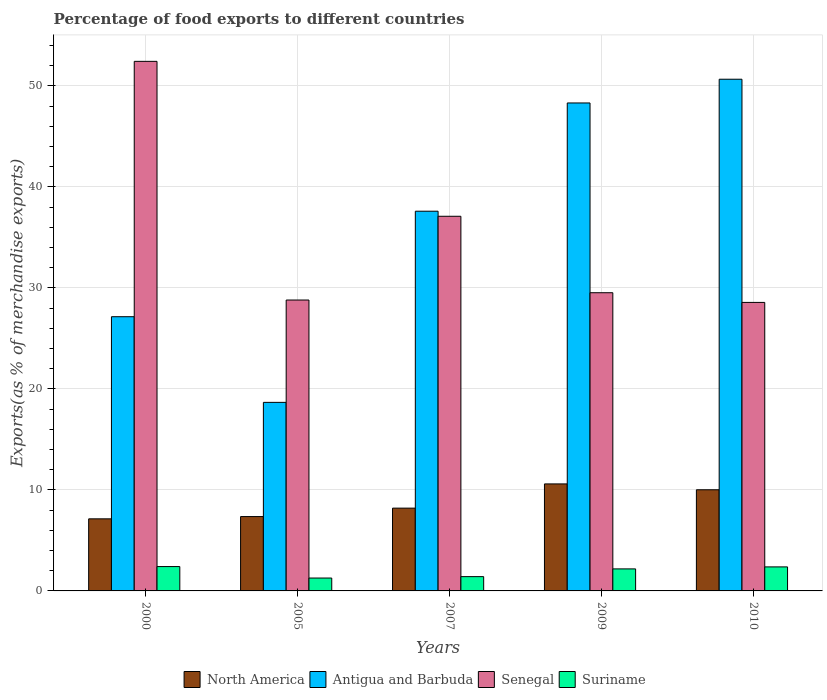How many groups of bars are there?
Offer a very short reply. 5. Are the number of bars per tick equal to the number of legend labels?
Your response must be concise. Yes. Are the number of bars on each tick of the X-axis equal?
Offer a terse response. Yes. How many bars are there on the 3rd tick from the right?
Ensure brevity in your answer.  4. What is the percentage of exports to different countries in Senegal in 2007?
Keep it short and to the point. 37.09. Across all years, what is the maximum percentage of exports to different countries in Suriname?
Keep it short and to the point. 2.41. Across all years, what is the minimum percentage of exports to different countries in Antigua and Barbuda?
Make the answer very short. 18.66. In which year was the percentage of exports to different countries in Senegal maximum?
Ensure brevity in your answer.  2000. What is the total percentage of exports to different countries in Senegal in the graph?
Provide a succinct answer. 176.39. What is the difference between the percentage of exports to different countries in Antigua and Barbuda in 2009 and that in 2010?
Ensure brevity in your answer.  -2.35. What is the difference between the percentage of exports to different countries in Senegal in 2000 and the percentage of exports to different countries in Suriname in 2007?
Offer a terse response. 51.01. What is the average percentage of exports to different countries in North America per year?
Your answer should be compact. 8.66. In the year 2005, what is the difference between the percentage of exports to different countries in Antigua and Barbuda and percentage of exports to different countries in North America?
Provide a short and direct response. 11.3. In how many years, is the percentage of exports to different countries in North America greater than 16 %?
Your answer should be compact. 0. What is the ratio of the percentage of exports to different countries in Antigua and Barbuda in 2000 to that in 2010?
Give a very brief answer. 0.54. Is the difference between the percentage of exports to different countries in Antigua and Barbuda in 2005 and 2010 greater than the difference between the percentage of exports to different countries in North America in 2005 and 2010?
Your response must be concise. No. What is the difference between the highest and the second highest percentage of exports to different countries in Senegal?
Your answer should be very brief. 15.34. What is the difference between the highest and the lowest percentage of exports to different countries in Senegal?
Provide a succinct answer. 23.86. In how many years, is the percentage of exports to different countries in Senegal greater than the average percentage of exports to different countries in Senegal taken over all years?
Your answer should be very brief. 2. What does the 2nd bar from the left in 2000 represents?
Offer a terse response. Antigua and Barbuda. What does the 3rd bar from the right in 2009 represents?
Make the answer very short. Antigua and Barbuda. Is it the case that in every year, the sum of the percentage of exports to different countries in Senegal and percentage of exports to different countries in North America is greater than the percentage of exports to different countries in Suriname?
Ensure brevity in your answer.  Yes. How many bars are there?
Your response must be concise. 20. Are the values on the major ticks of Y-axis written in scientific E-notation?
Your response must be concise. No. Does the graph contain any zero values?
Offer a terse response. No. How many legend labels are there?
Provide a succinct answer. 4. How are the legend labels stacked?
Give a very brief answer. Horizontal. What is the title of the graph?
Your answer should be compact. Percentage of food exports to different countries. What is the label or title of the X-axis?
Provide a succinct answer. Years. What is the label or title of the Y-axis?
Offer a terse response. Exports(as % of merchandise exports). What is the Exports(as % of merchandise exports) in North America in 2000?
Make the answer very short. 7.14. What is the Exports(as % of merchandise exports) of Antigua and Barbuda in 2000?
Keep it short and to the point. 27.15. What is the Exports(as % of merchandise exports) of Senegal in 2000?
Provide a short and direct response. 52.42. What is the Exports(as % of merchandise exports) in Suriname in 2000?
Ensure brevity in your answer.  2.41. What is the Exports(as % of merchandise exports) in North America in 2005?
Your answer should be compact. 7.36. What is the Exports(as % of merchandise exports) in Antigua and Barbuda in 2005?
Keep it short and to the point. 18.66. What is the Exports(as % of merchandise exports) in Senegal in 2005?
Offer a terse response. 28.8. What is the Exports(as % of merchandise exports) of Suriname in 2005?
Give a very brief answer. 1.27. What is the Exports(as % of merchandise exports) of North America in 2007?
Your answer should be very brief. 8.2. What is the Exports(as % of merchandise exports) in Antigua and Barbuda in 2007?
Offer a terse response. 37.59. What is the Exports(as % of merchandise exports) in Senegal in 2007?
Make the answer very short. 37.09. What is the Exports(as % of merchandise exports) of Suriname in 2007?
Your answer should be very brief. 1.42. What is the Exports(as % of merchandise exports) of North America in 2009?
Offer a terse response. 10.59. What is the Exports(as % of merchandise exports) of Antigua and Barbuda in 2009?
Offer a very short reply. 48.31. What is the Exports(as % of merchandise exports) in Senegal in 2009?
Provide a short and direct response. 29.52. What is the Exports(as % of merchandise exports) in Suriname in 2009?
Provide a short and direct response. 2.18. What is the Exports(as % of merchandise exports) of North America in 2010?
Make the answer very short. 10.01. What is the Exports(as % of merchandise exports) of Antigua and Barbuda in 2010?
Offer a terse response. 50.65. What is the Exports(as % of merchandise exports) of Senegal in 2010?
Offer a very short reply. 28.56. What is the Exports(as % of merchandise exports) of Suriname in 2010?
Your answer should be compact. 2.38. Across all years, what is the maximum Exports(as % of merchandise exports) of North America?
Your response must be concise. 10.59. Across all years, what is the maximum Exports(as % of merchandise exports) in Antigua and Barbuda?
Make the answer very short. 50.65. Across all years, what is the maximum Exports(as % of merchandise exports) of Senegal?
Provide a succinct answer. 52.42. Across all years, what is the maximum Exports(as % of merchandise exports) in Suriname?
Offer a terse response. 2.41. Across all years, what is the minimum Exports(as % of merchandise exports) in North America?
Ensure brevity in your answer.  7.14. Across all years, what is the minimum Exports(as % of merchandise exports) in Antigua and Barbuda?
Your response must be concise. 18.66. Across all years, what is the minimum Exports(as % of merchandise exports) in Senegal?
Make the answer very short. 28.56. Across all years, what is the minimum Exports(as % of merchandise exports) of Suriname?
Keep it short and to the point. 1.27. What is the total Exports(as % of merchandise exports) in North America in the graph?
Offer a very short reply. 43.3. What is the total Exports(as % of merchandise exports) of Antigua and Barbuda in the graph?
Offer a very short reply. 182.36. What is the total Exports(as % of merchandise exports) of Senegal in the graph?
Your answer should be very brief. 176.39. What is the total Exports(as % of merchandise exports) in Suriname in the graph?
Provide a short and direct response. 9.66. What is the difference between the Exports(as % of merchandise exports) of North America in 2000 and that in 2005?
Your answer should be compact. -0.22. What is the difference between the Exports(as % of merchandise exports) of Antigua and Barbuda in 2000 and that in 2005?
Offer a very short reply. 8.48. What is the difference between the Exports(as % of merchandise exports) of Senegal in 2000 and that in 2005?
Offer a very short reply. 23.63. What is the difference between the Exports(as % of merchandise exports) of Suriname in 2000 and that in 2005?
Give a very brief answer. 1.14. What is the difference between the Exports(as % of merchandise exports) of North America in 2000 and that in 2007?
Your answer should be very brief. -1.06. What is the difference between the Exports(as % of merchandise exports) in Antigua and Barbuda in 2000 and that in 2007?
Your answer should be very brief. -10.44. What is the difference between the Exports(as % of merchandise exports) in Senegal in 2000 and that in 2007?
Your response must be concise. 15.34. What is the difference between the Exports(as % of merchandise exports) in North America in 2000 and that in 2009?
Offer a very short reply. -3.46. What is the difference between the Exports(as % of merchandise exports) in Antigua and Barbuda in 2000 and that in 2009?
Your answer should be compact. -21.16. What is the difference between the Exports(as % of merchandise exports) of Senegal in 2000 and that in 2009?
Your answer should be very brief. 22.9. What is the difference between the Exports(as % of merchandise exports) of Suriname in 2000 and that in 2009?
Give a very brief answer. 0.23. What is the difference between the Exports(as % of merchandise exports) of North America in 2000 and that in 2010?
Ensure brevity in your answer.  -2.88. What is the difference between the Exports(as % of merchandise exports) of Antigua and Barbuda in 2000 and that in 2010?
Offer a terse response. -23.51. What is the difference between the Exports(as % of merchandise exports) of Senegal in 2000 and that in 2010?
Your response must be concise. 23.86. What is the difference between the Exports(as % of merchandise exports) of Suriname in 2000 and that in 2010?
Provide a short and direct response. 0.03. What is the difference between the Exports(as % of merchandise exports) in North America in 2005 and that in 2007?
Give a very brief answer. -0.84. What is the difference between the Exports(as % of merchandise exports) of Antigua and Barbuda in 2005 and that in 2007?
Provide a short and direct response. -18.92. What is the difference between the Exports(as % of merchandise exports) in Senegal in 2005 and that in 2007?
Provide a succinct answer. -8.29. What is the difference between the Exports(as % of merchandise exports) of Suriname in 2005 and that in 2007?
Ensure brevity in your answer.  -0.14. What is the difference between the Exports(as % of merchandise exports) of North America in 2005 and that in 2009?
Ensure brevity in your answer.  -3.23. What is the difference between the Exports(as % of merchandise exports) of Antigua and Barbuda in 2005 and that in 2009?
Provide a succinct answer. -29.64. What is the difference between the Exports(as % of merchandise exports) of Senegal in 2005 and that in 2009?
Give a very brief answer. -0.72. What is the difference between the Exports(as % of merchandise exports) in Suriname in 2005 and that in 2009?
Offer a very short reply. -0.9. What is the difference between the Exports(as % of merchandise exports) of North America in 2005 and that in 2010?
Make the answer very short. -2.65. What is the difference between the Exports(as % of merchandise exports) in Antigua and Barbuda in 2005 and that in 2010?
Ensure brevity in your answer.  -31.99. What is the difference between the Exports(as % of merchandise exports) in Senegal in 2005 and that in 2010?
Your answer should be very brief. 0.24. What is the difference between the Exports(as % of merchandise exports) in Suriname in 2005 and that in 2010?
Provide a succinct answer. -1.1. What is the difference between the Exports(as % of merchandise exports) of North America in 2007 and that in 2009?
Offer a very short reply. -2.4. What is the difference between the Exports(as % of merchandise exports) of Antigua and Barbuda in 2007 and that in 2009?
Keep it short and to the point. -10.72. What is the difference between the Exports(as % of merchandise exports) in Senegal in 2007 and that in 2009?
Give a very brief answer. 7.57. What is the difference between the Exports(as % of merchandise exports) of Suriname in 2007 and that in 2009?
Provide a succinct answer. -0.76. What is the difference between the Exports(as % of merchandise exports) in North America in 2007 and that in 2010?
Your response must be concise. -1.82. What is the difference between the Exports(as % of merchandise exports) of Antigua and Barbuda in 2007 and that in 2010?
Ensure brevity in your answer.  -13.07. What is the difference between the Exports(as % of merchandise exports) of Senegal in 2007 and that in 2010?
Offer a terse response. 8.53. What is the difference between the Exports(as % of merchandise exports) of Suriname in 2007 and that in 2010?
Your answer should be compact. -0.96. What is the difference between the Exports(as % of merchandise exports) in North America in 2009 and that in 2010?
Your response must be concise. 0.58. What is the difference between the Exports(as % of merchandise exports) of Antigua and Barbuda in 2009 and that in 2010?
Offer a very short reply. -2.35. What is the difference between the Exports(as % of merchandise exports) of Senegal in 2009 and that in 2010?
Make the answer very short. 0.96. What is the difference between the Exports(as % of merchandise exports) in Suriname in 2009 and that in 2010?
Offer a very short reply. -0.2. What is the difference between the Exports(as % of merchandise exports) of North America in 2000 and the Exports(as % of merchandise exports) of Antigua and Barbuda in 2005?
Offer a terse response. -11.53. What is the difference between the Exports(as % of merchandise exports) in North America in 2000 and the Exports(as % of merchandise exports) in Senegal in 2005?
Offer a terse response. -21.66. What is the difference between the Exports(as % of merchandise exports) of North America in 2000 and the Exports(as % of merchandise exports) of Suriname in 2005?
Ensure brevity in your answer.  5.86. What is the difference between the Exports(as % of merchandise exports) in Antigua and Barbuda in 2000 and the Exports(as % of merchandise exports) in Senegal in 2005?
Your answer should be very brief. -1.65. What is the difference between the Exports(as % of merchandise exports) in Antigua and Barbuda in 2000 and the Exports(as % of merchandise exports) in Suriname in 2005?
Ensure brevity in your answer.  25.87. What is the difference between the Exports(as % of merchandise exports) of Senegal in 2000 and the Exports(as % of merchandise exports) of Suriname in 2005?
Ensure brevity in your answer.  51.15. What is the difference between the Exports(as % of merchandise exports) of North America in 2000 and the Exports(as % of merchandise exports) of Antigua and Barbuda in 2007?
Your response must be concise. -30.45. What is the difference between the Exports(as % of merchandise exports) in North America in 2000 and the Exports(as % of merchandise exports) in Senegal in 2007?
Provide a short and direct response. -29.95. What is the difference between the Exports(as % of merchandise exports) in North America in 2000 and the Exports(as % of merchandise exports) in Suriname in 2007?
Offer a very short reply. 5.72. What is the difference between the Exports(as % of merchandise exports) of Antigua and Barbuda in 2000 and the Exports(as % of merchandise exports) of Senegal in 2007?
Offer a very short reply. -9.94. What is the difference between the Exports(as % of merchandise exports) in Antigua and Barbuda in 2000 and the Exports(as % of merchandise exports) in Suriname in 2007?
Make the answer very short. 25.73. What is the difference between the Exports(as % of merchandise exports) of Senegal in 2000 and the Exports(as % of merchandise exports) of Suriname in 2007?
Make the answer very short. 51.01. What is the difference between the Exports(as % of merchandise exports) of North America in 2000 and the Exports(as % of merchandise exports) of Antigua and Barbuda in 2009?
Offer a terse response. -41.17. What is the difference between the Exports(as % of merchandise exports) of North America in 2000 and the Exports(as % of merchandise exports) of Senegal in 2009?
Your answer should be very brief. -22.38. What is the difference between the Exports(as % of merchandise exports) of North America in 2000 and the Exports(as % of merchandise exports) of Suriname in 2009?
Your response must be concise. 4.96. What is the difference between the Exports(as % of merchandise exports) in Antigua and Barbuda in 2000 and the Exports(as % of merchandise exports) in Senegal in 2009?
Keep it short and to the point. -2.37. What is the difference between the Exports(as % of merchandise exports) of Antigua and Barbuda in 2000 and the Exports(as % of merchandise exports) of Suriname in 2009?
Provide a short and direct response. 24.97. What is the difference between the Exports(as % of merchandise exports) in Senegal in 2000 and the Exports(as % of merchandise exports) in Suriname in 2009?
Offer a terse response. 50.24. What is the difference between the Exports(as % of merchandise exports) in North America in 2000 and the Exports(as % of merchandise exports) in Antigua and Barbuda in 2010?
Offer a terse response. -43.52. What is the difference between the Exports(as % of merchandise exports) of North America in 2000 and the Exports(as % of merchandise exports) of Senegal in 2010?
Offer a very short reply. -21.42. What is the difference between the Exports(as % of merchandise exports) in North America in 2000 and the Exports(as % of merchandise exports) in Suriname in 2010?
Your answer should be compact. 4.76. What is the difference between the Exports(as % of merchandise exports) of Antigua and Barbuda in 2000 and the Exports(as % of merchandise exports) of Senegal in 2010?
Ensure brevity in your answer.  -1.41. What is the difference between the Exports(as % of merchandise exports) of Antigua and Barbuda in 2000 and the Exports(as % of merchandise exports) of Suriname in 2010?
Provide a short and direct response. 24.77. What is the difference between the Exports(as % of merchandise exports) of Senegal in 2000 and the Exports(as % of merchandise exports) of Suriname in 2010?
Provide a succinct answer. 50.05. What is the difference between the Exports(as % of merchandise exports) of North America in 2005 and the Exports(as % of merchandise exports) of Antigua and Barbuda in 2007?
Give a very brief answer. -30.23. What is the difference between the Exports(as % of merchandise exports) of North America in 2005 and the Exports(as % of merchandise exports) of Senegal in 2007?
Your answer should be compact. -29.73. What is the difference between the Exports(as % of merchandise exports) of North America in 2005 and the Exports(as % of merchandise exports) of Suriname in 2007?
Offer a very short reply. 5.95. What is the difference between the Exports(as % of merchandise exports) of Antigua and Barbuda in 2005 and the Exports(as % of merchandise exports) of Senegal in 2007?
Offer a terse response. -18.42. What is the difference between the Exports(as % of merchandise exports) of Antigua and Barbuda in 2005 and the Exports(as % of merchandise exports) of Suriname in 2007?
Your response must be concise. 17.25. What is the difference between the Exports(as % of merchandise exports) of Senegal in 2005 and the Exports(as % of merchandise exports) of Suriname in 2007?
Make the answer very short. 27.38. What is the difference between the Exports(as % of merchandise exports) in North America in 2005 and the Exports(as % of merchandise exports) in Antigua and Barbuda in 2009?
Provide a succinct answer. -40.94. What is the difference between the Exports(as % of merchandise exports) of North America in 2005 and the Exports(as % of merchandise exports) of Senegal in 2009?
Give a very brief answer. -22.16. What is the difference between the Exports(as % of merchandise exports) in North America in 2005 and the Exports(as % of merchandise exports) in Suriname in 2009?
Your response must be concise. 5.18. What is the difference between the Exports(as % of merchandise exports) in Antigua and Barbuda in 2005 and the Exports(as % of merchandise exports) in Senegal in 2009?
Give a very brief answer. -10.85. What is the difference between the Exports(as % of merchandise exports) in Antigua and Barbuda in 2005 and the Exports(as % of merchandise exports) in Suriname in 2009?
Keep it short and to the point. 16.49. What is the difference between the Exports(as % of merchandise exports) of Senegal in 2005 and the Exports(as % of merchandise exports) of Suriname in 2009?
Offer a terse response. 26.62. What is the difference between the Exports(as % of merchandise exports) of North America in 2005 and the Exports(as % of merchandise exports) of Antigua and Barbuda in 2010?
Ensure brevity in your answer.  -43.29. What is the difference between the Exports(as % of merchandise exports) of North America in 2005 and the Exports(as % of merchandise exports) of Senegal in 2010?
Offer a very short reply. -21.2. What is the difference between the Exports(as % of merchandise exports) in North America in 2005 and the Exports(as % of merchandise exports) in Suriname in 2010?
Give a very brief answer. 4.98. What is the difference between the Exports(as % of merchandise exports) of Antigua and Barbuda in 2005 and the Exports(as % of merchandise exports) of Senegal in 2010?
Provide a short and direct response. -9.89. What is the difference between the Exports(as % of merchandise exports) in Antigua and Barbuda in 2005 and the Exports(as % of merchandise exports) in Suriname in 2010?
Provide a short and direct response. 16.29. What is the difference between the Exports(as % of merchandise exports) of Senegal in 2005 and the Exports(as % of merchandise exports) of Suriname in 2010?
Provide a succinct answer. 26.42. What is the difference between the Exports(as % of merchandise exports) in North America in 2007 and the Exports(as % of merchandise exports) in Antigua and Barbuda in 2009?
Your answer should be compact. -40.11. What is the difference between the Exports(as % of merchandise exports) of North America in 2007 and the Exports(as % of merchandise exports) of Senegal in 2009?
Provide a succinct answer. -21.32. What is the difference between the Exports(as % of merchandise exports) of North America in 2007 and the Exports(as % of merchandise exports) of Suriname in 2009?
Offer a very short reply. 6.02. What is the difference between the Exports(as % of merchandise exports) in Antigua and Barbuda in 2007 and the Exports(as % of merchandise exports) in Senegal in 2009?
Your response must be concise. 8.07. What is the difference between the Exports(as % of merchandise exports) in Antigua and Barbuda in 2007 and the Exports(as % of merchandise exports) in Suriname in 2009?
Keep it short and to the point. 35.41. What is the difference between the Exports(as % of merchandise exports) of Senegal in 2007 and the Exports(as % of merchandise exports) of Suriname in 2009?
Your answer should be very brief. 34.91. What is the difference between the Exports(as % of merchandise exports) of North America in 2007 and the Exports(as % of merchandise exports) of Antigua and Barbuda in 2010?
Your answer should be very brief. -42.46. What is the difference between the Exports(as % of merchandise exports) in North America in 2007 and the Exports(as % of merchandise exports) in Senegal in 2010?
Your answer should be very brief. -20.36. What is the difference between the Exports(as % of merchandise exports) of North America in 2007 and the Exports(as % of merchandise exports) of Suriname in 2010?
Your answer should be very brief. 5.82. What is the difference between the Exports(as % of merchandise exports) in Antigua and Barbuda in 2007 and the Exports(as % of merchandise exports) in Senegal in 2010?
Give a very brief answer. 9.03. What is the difference between the Exports(as % of merchandise exports) of Antigua and Barbuda in 2007 and the Exports(as % of merchandise exports) of Suriname in 2010?
Offer a terse response. 35.21. What is the difference between the Exports(as % of merchandise exports) of Senegal in 2007 and the Exports(as % of merchandise exports) of Suriname in 2010?
Keep it short and to the point. 34.71. What is the difference between the Exports(as % of merchandise exports) in North America in 2009 and the Exports(as % of merchandise exports) in Antigua and Barbuda in 2010?
Your response must be concise. -40.06. What is the difference between the Exports(as % of merchandise exports) in North America in 2009 and the Exports(as % of merchandise exports) in Senegal in 2010?
Your answer should be very brief. -17.97. What is the difference between the Exports(as % of merchandise exports) of North America in 2009 and the Exports(as % of merchandise exports) of Suriname in 2010?
Provide a succinct answer. 8.21. What is the difference between the Exports(as % of merchandise exports) of Antigua and Barbuda in 2009 and the Exports(as % of merchandise exports) of Senegal in 2010?
Offer a very short reply. 19.75. What is the difference between the Exports(as % of merchandise exports) of Antigua and Barbuda in 2009 and the Exports(as % of merchandise exports) of Suriname in 2010?
Your response must be concise. 45.93. What is the difference between the Exports(as % of merchandise exports) in Senegal in 2009 and the Exports(as % of merchandise exports) in Suriname in 2010?
Ensure brevity in your answer.  27.14. What is the average Exports(as % of merchandise exports) of North America per year?
Your response must be concise. 8.66. What is the average Exports(as % of merchandise exports) in Antigua and Barbuda per year?
Keep it short and to the point. 36.47. What is the average Exports(as % of merchandise exports) of Senegal per year?
Offer a very short reply. 35.28. What is the average Exports(as % of merchandise exports) in Suriname per year?
Your answer should be very brief. 1.93. In the year 2000, what is the difference between the Exports(as % of merchandise exports) of North America and Exports(as % of merchandise exports) of Antigua and Barbuda?
Your response must be concise. -20.01. In the year 2000, what is the difference between the Exports(as % of merchandise exports) of North America and Exports(as % of merchandise exports) of Senegal?
Provide a short and direct response. -45.29. In the year 2000, what is the difference between the Exports(as % of merchandise exports) of North America and Exports(as % of merchandise exports) of Suriname?
Give a very brief answer. 4.72. In the year 2000, what is the difference between the Exports(as % of merchandise exports) in Antigua and Barbuda and Exports(as % of merchandise exports) in Senegal?
Provide a short and direct response. -25.28. In the year 2000, what is the difference between the Exports(as % of merchandise exports) in Antigua and Barbuda and Exports(as % of merchandise exports) in Suriname?
Ensure brevity in your answer.  24.73. In the year 2000, what is the difference between the Exports(as % of merchandise exports) in Senegal and Exports(as % of merchandise exports) in Suriname?
Keep it short and to the point. 50.01. In the year 2005, what is the difference between the Exports(as % of merchandise exports) in North America and Exports(as % of merchandise exports) in Antigua and Barbuda?
Your answer should be compact. -11.3. In the year 2005, what is the difference between the Exports(as % of merchandise exports) of North America and Exports(as % of merchandise exports) of Senegal?
Offer a terse response. -21.44. In the year 2005, what is the difference between the Exports(as % of merchandise exports) in North America and Exports(as % of merchandise exports) in Suriname?
Provide a succinct answer. 6.09. In the year 2005, what is the difference between the Exports(as % of merchandise exports) of Antigua and Barbuda and Exports(as % of merchandise exports) of Senegal?
Ensure brevity in your answer.  -10.13. In the year 2005, what is the difference between the Exports(as % of merchandise exports) of Antigua and Barbuda and Exports(as % of merchandise exports) of Suriname?
Your response must be concise. 17.39. In the year 2005, what is the difference between the Exports(as % of merchandise exports) in Senegal and Exports(as % of merchandise exports) in Suriname?
Provide a short and direct response. 27.52. In the year 2007, what is the difference between the Exports(as % of merchandise exports) of North America and Exports(as % of merchandise exports) of Antigua and Barbuda?
Your answer should be compact. -29.39. In the year 2007, what is the difference between the Exports(as % of merchandise exports) of North America and Exports(as % of merchandise exports) of Senegal?
Your answer should be compact. -28.89. In the year 2007, what is the difference between the Exports(as % of merchandise exports) in North America and Exports(as % of merchandise exports) in Suriname?
Your answer should be compact. 6.78. In the year 2007, what is the difference between the Exports(as % of merchandise exports) of Antigua and Barbuda and Exports(as % of merchandise exports) of Senegal?
Offer a terse response. 0.5. In the year 2007, what is the difference between the Exports(as % of merchandise exports) of Antigua and Barbuda and Exports(as % of merchandise exports) of Suriname?
Make the answer very short. 36.17. In the year 2007, what is the difference between the Exports(as % of merchandise exports) of Senegal and Exports(as % of merchandise exports) of Suriname?
Provide a succinct answer. 35.67. In the year 2009, what is the difference between the Exports(as % of merchandise exports) of North America and Exports(as % of merchandise exports) of Antigua and Barbuda?
Your answer should be compact. -37.71. In the year 2009, what is the difference between the Exports(as % of merchandise exports) in North America and Exports(as % of merchandise exports) in Senegal?
Your answer should be very brief. -18.93. In the year 2009, what is the difference between the Exports(as % of merchandise exports) in North America and Exports(as % of merchandise exports) in Suriname?
Provide a succinct answer. 8.41. In the year 2009, what is the difference between the Exports(as % of merchandise exports) of Antigua and Barbuda and Exports(as % of merchandise exports) of Senegal?
Offer a terse response. 18.79. In the year 2009, what is the difference between the Exports(as % of merchandise exports) of Antigua and Barbuda and Exports(as % of merchandise exports) of Suriname?
Provide a succinct answer. 46.13. In the year 2009, what is the difference between the Exports(as % of merchandise exports) in Senegal and Exports(as % of merchandise exports) in Suriname?
Ensure brevity in your answer.  27.34. In the year 2010, what is the difference between the Exports(as % of merchandise exports) in North America and Exports(as % of merchandise exports) in Antigua and Barbuda?
Provide a succinct answer. -40.64. In the year 2010, what is the difference between the Exports(as % of merchandise exports) in North America and Exports(as % of merchandise exports) in Senegal?
Provide a short and direct response. -18.55. In the year 2010, what is the difference between the Exports(as % of merchandise exports) in North America and Exports(as % of merchandise exports) in Suriname?
Offer a terse response. 7.63. In the year 2010, what is the difference between the Exports(as % of merchandise exports) in Antigua and Barbuda and Exports(as % of merchandise exports) in Senegal?
Give a very brief answer. 22.09. In the year 2010, what is the difference between the Exports(as % of merchandise exports) of Antigua and Barbuda and Exports(as % of merchandise exports) of Suriname?
Offer a terse response. 48.28. In the year 2010, what is the difference between the Exports(as % of merchandise exports) in Senegal and Exports(as % of merchandise exports) in Suriname?
Your answer should be very brief. 26.18. What is the ratio of the Exports(as % of merchandise exports) in North America in 2000 to that in 2005?
Your answer should be very brief. 0.97. What is the ratio of the Exports(as % of merchandise exports) in Antigua and Barbuda in 2000 to that in 2005?
Offer a very short reply. 1.45. What is the ratio of the Exports(as % of merchandise exports) in Senegal in 2000 to that in 2005?
Provide a short and direct response. 1.82. What is the ratio of the Exports(as % of merchandise exports) of Suriname in 2000 to that in 2005?
Ensure brevity in your answer.  1.89. What is the ratio of the Exports(as % of merchandise exports) of North America in 2000 to that in 2007?
Make the answer very short. 0.87. What is the ratio of the Exports(as % of merchandise exports) of Antigua and Barbuda in 2000 to that in 2007?
Offer a terse response. 0.72. What is the ratio of the Exports(as % of merchandise exports) in Senegal in 2000 to that in 2007?
Provide a succinct answer. 1.41. What is the ratio of the Exports(as % of merchandise exports) in Suriname in 2000 to that in 2007?
Provide a succinct answer. 1.7. What is the ratio of the Exports(as % of merchandise exports) of North America in 2000 to that in 2009?
Make the answer very short. 0.67. What is the ratio of the Exports(as % of merchandise exports) in Antigua and Barbuda in 2000 to that in 2009?
Your answer should be compact. 0.56. What is the ratio of the Exports(as % of merchandise exports) of Senegal in 2000 to that in 2009?
Your response must be concise. 1.78. What is the ratio of the Exports(as % of merchandise exports) of Suriname in 2000 to that in 2009?
Your response must be concise. 1.11. What is the ratio of the Exports(as % of merchandise exports) of North America in 2000 to that in 2010?
Provide a short and direct response. 0.71. What is the ratio of the Exports(as % of merchandise exports) of Antigua and Barbuda in 2000 to that in 2010?
Offer a terse response. 0.54. What is the ratio of the Exports(as % of merchandise exports) in Senegal in 2000 to that in 2010?
Keep it short and to the point. 1.84. What is the ratio of the Exports(as % of merchandise exports) in Suriname in 2000 to that in 2010?
Provide a succinct answer. 1.01. What is the ratio of the Exports(as % of merchandise exports) in North America in 2005 to that in 2007?
Ensure brevity in your answer.  0.9. What is the ratio of the Exports(as % of merchandise exports) in Antigua and Barbuda in 2005 to that in 2007?
Your answer should be compact. 0.5. What is the ratio of the Exports(as % of merchandise exports) of Senegal in 2005 to that in 2007?
Make the answer very short. 0.78. What is the ratio of the Exports(as % of merchandise exports) in Suriname in 2005 to that in 2007?
Offer a terse response. 0.9. What is the ratio of the Exports(as % of merchandise exports) of North America in 2005 to that in 2009?
Provide a succinct answer. 0.69. What is the ratio of the Exports(as % of merchandise exports) of Antigua and Barbuda in 2005 to that in 2009?
Provide a succinct answer. 0.39. What is the ratio of the Exports(as % of merchandise exports) in Senegal in 2005 to that in 2009?
Keep it short and to the point. 0.98. What is the ratio of the Exports(as % of merchandise exports) in Suriname in 2005 to that in 2009?
Make the answer very short. 0.58. What is the ratio of the Exports(as % of merchandise exports) in North America in 2005 to that in 2010?
Give a very brief answer. 0.73. What is the ratio of the Exports(as % of merchandise exports) in Antigua and Barbuda in 2005 to that in 2010?
Your answer should be very brief. 0.37. What is the ratio of the Exports(as % of merchandise exports) of Senegal in 2005 to that in 2010?
Provide a short and direct response. 1.01. What is the ratio of the Exports(as % of merchandise exports) in Suriname in 2005 to that in 2010?
Your response must be concise. 0.54. What is the ratio of the Exports(as % of merchandise exports) in North America in 2007 to that in 2009?
Ensure brevity in your answer.  0.77. What is the ratio of the Exports(as % of merchandise exports) of Antigua and Barbuda in 2007 to that in 2009?
Provide a succinct answer. 0.78. What is the ratio of the Exports(as % of merchandise exports) of Senegal in 2007 to that in 2009?
Your response must be concise. 1.26. What is the ratio of the Exports(as % of merchandise exports) of Suriname in 2007 to that in 2009?
Offer a very short reply. 0.65. What is the ratio of the Exports(as % of merchandise exports) of North America in 2007 to that in 2010?
Offer a very short reply. 0.82. What is the ratio of the Exports(as % of merchandise exports) in Antigua and Barbuda in 2007 to that in 2010?
Give a very brief answer. 0.74. What is the ratio of the Exports(as % of merchandise exports) of Senegal in 2007 to that in 2010?
Offer a terse response. 1.3. What is the ratio of the Exports(as % of merchandise exports) in Suriname in 2007 to that in 2010?
Offer a terse response. 0.59. What is the ratio of the Exports(as % of merchandise exports) in North America in 2009 to that in 2010?
Your answer should be very brief. 1.06. What is the ratio of the Exports(as % of merchandise exports) of Antigua and Barbuda in 2009 to that in 2010?
Provide a short and direct response. 0.95. What is the ratio of the Exports(as % of merchandise exports) in Senegal in 2009 to that in 2010?
Offer a very short reply. 1.03. What is the ratio of the Exports(as % of merchandise exports) of Suriname in 2009 to that in 2010?
Keep it short and to the point. 0.92. What is the difference between the highest and the second highest Exports(as % of merchandise exports) of North America?
Your response must be concise. 0.58. What is the difference between the highest and the second highest Exports(as % of merchandise exports) in Antigua and Barbuda?
Your response must be concise. 2.35. What is the difference between the highest and the second highest Exports(as % of merchandise exports) in Senegal?
Offer a very short reply. 15.34. What is the difference between the highest and the second highest Exports(as % of merchandise exports) of Suriname?
Provide a succinct answer. 0.03. What is the difference between the highest and the lowest Exports(as % of merchandise exports) in North America?
Your answer should be very brief. 3.46. What is the difference between the highest and the lowest Exports(as % of merchandise exports) of Antigua and Barbuda?
Provide a succinct answer. 31.99. What is the difference between the highest and the lowest Exports(as % of merchandise exports) of Senegal?
Keep it short and to the point. 23.86. What is the difference between the highest and the lowest Exports(as % of merchandise exports) in Suriname?
Provide a succinct answer. 1.14. 